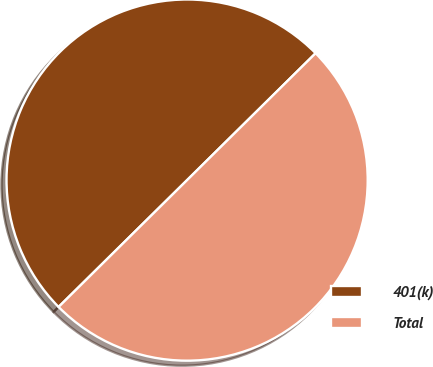Convert chart to OTSL. <chart><loc_0><loc_0><loc_500><loc_500><pie_chart><fcel>401(k)<fcel>Total<nl><fcel>50.0%<fcel>50.0%<nl></chart> 